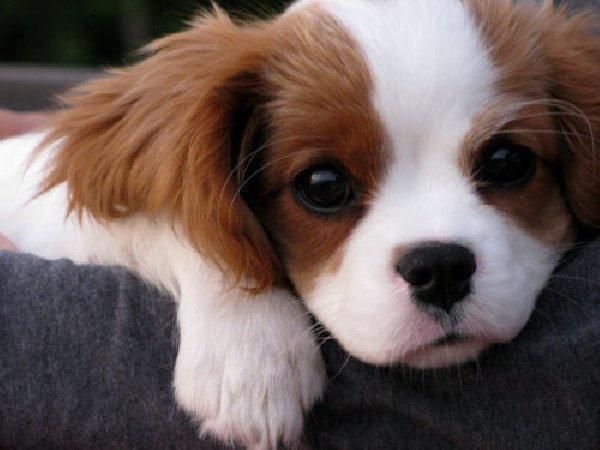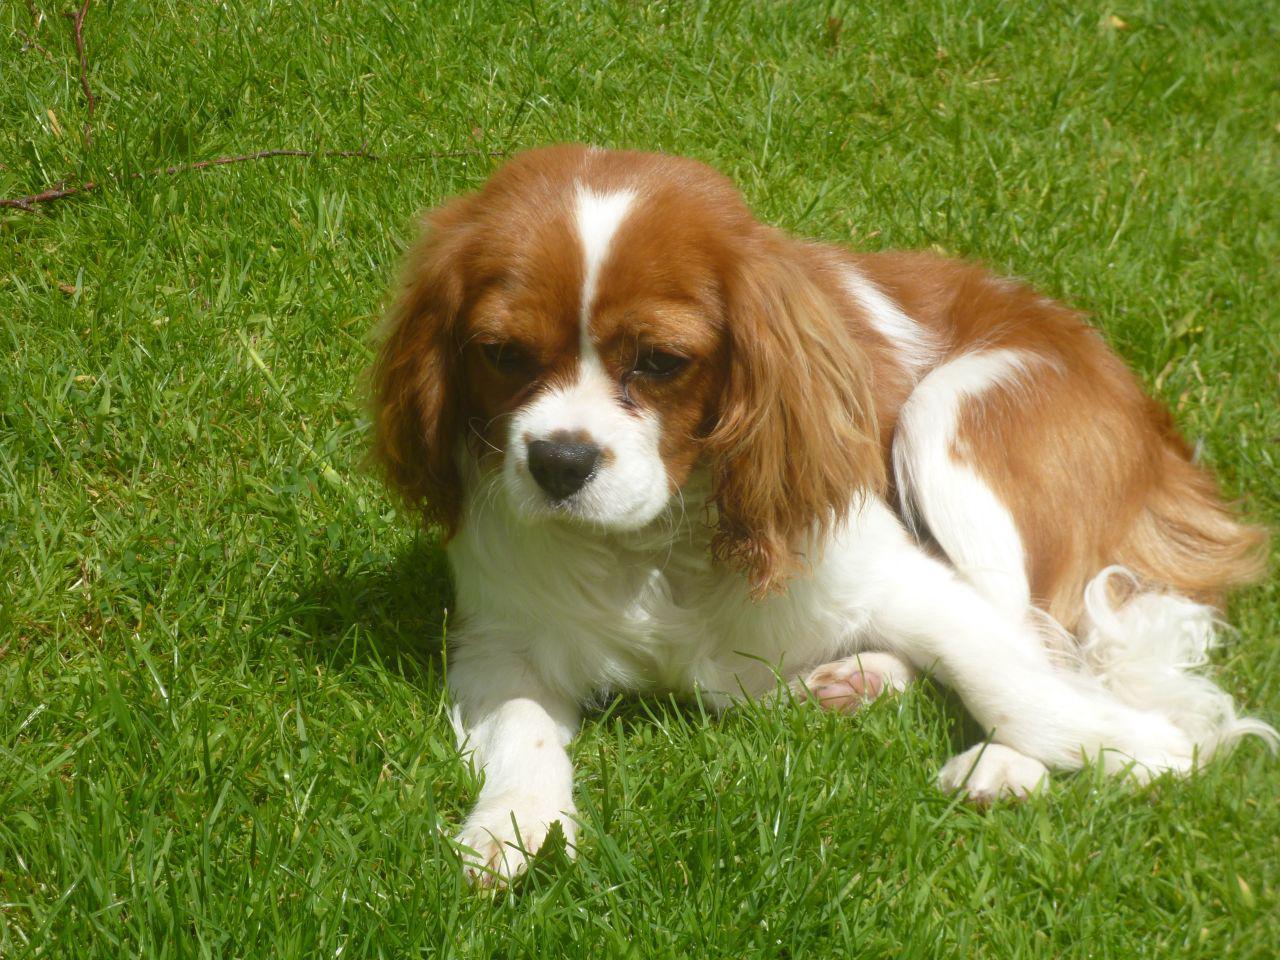The first image is the image on the left, the second image is the image on the right. Examine the images to the left and right. Is the description "There are exactly two Cavalier King Charles puppies on the pair of images." accurate? Answer yes or no. Yes. The first image is the image on the left, the second image is the image on the right. Evaluate the accuracy of this statement regarding the images: "There are at most two dogs.". Is it true? Answer yes or no. Yes. 